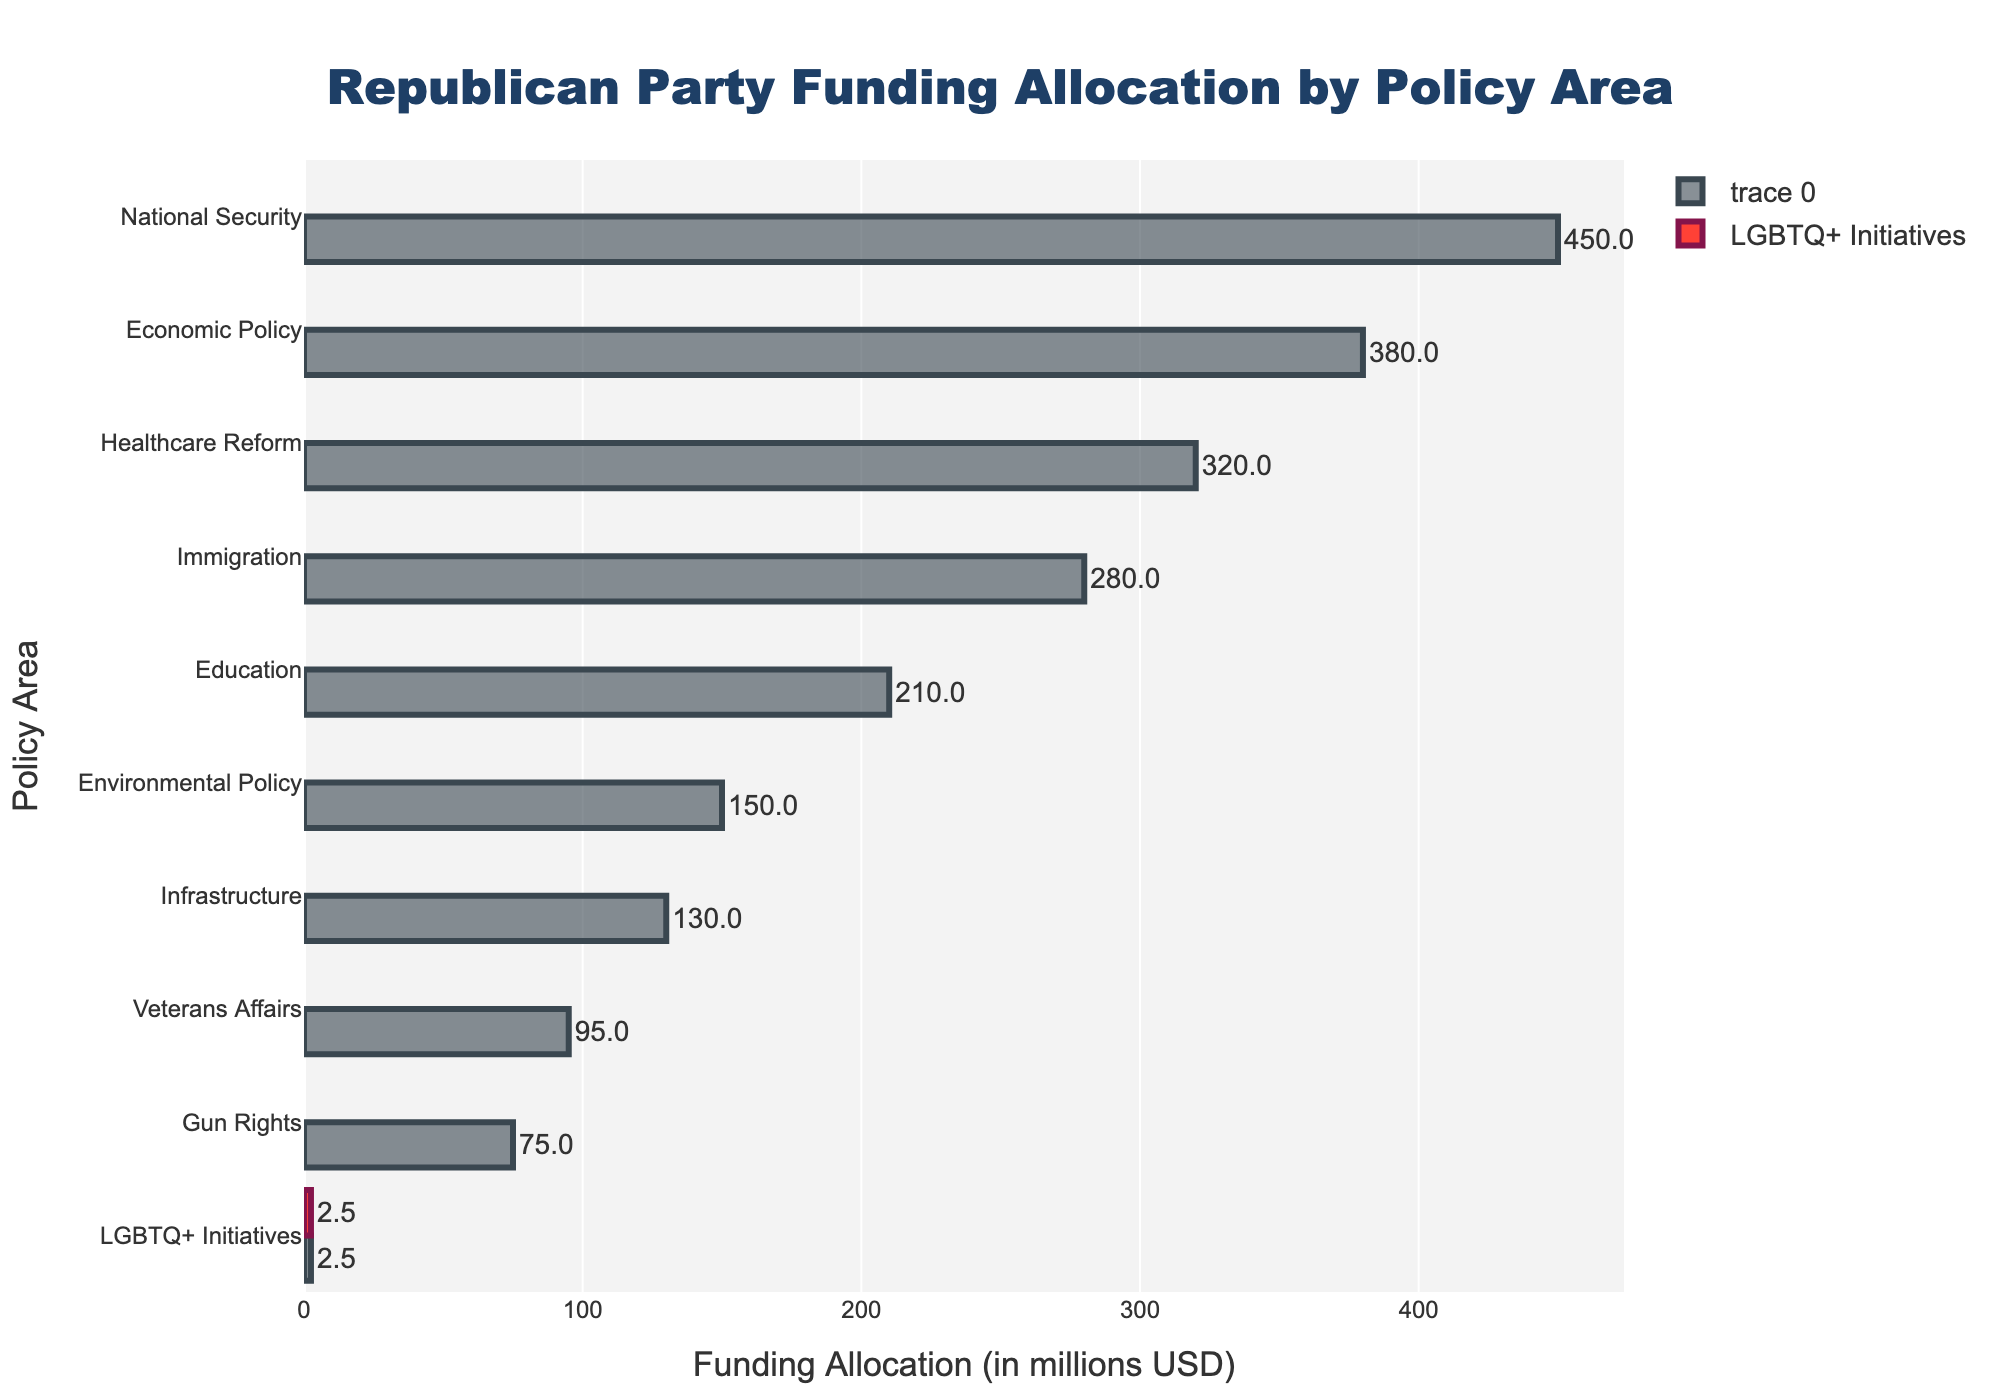How much more funding is allocated to National Security compared to LGBTQ+ Initiatives? The funding for National Security is 450 million USD, and the funding for LGBTQ+ Initiatives is 2.5 million USD. The difference is 450 - 2.5 = 447.5 million USD.
Answer: 447.5 million USD What is the total funding allocation for Economic Policy, Healthcare Reform, and Immigration combined? The funding for Economic Policy is 380 million USD, for Healthcare Reform is 320 million USD, and for Immigration is 280 million USD. The sum is 380 + 320 + 280 = 980 million USD.
Answer: 980 million USD Rank the policy areas from highest to lowest funding allocation. By looking at the bar lengths, the ranking from highest to lowest funding allocation is National Security, Economic Policy, Healthcare Reform, Immigration, Education, Environmental Policy, Infrastructure, Veterans Affairs, Gun Rights, LGBTQ+ Initiatives.
Answer: National Security, Economic Policy, Healthcare Reform, Immigration, Education, Environmental Policy, Infrastructure, Veterans Affairs, Gun Rights, LGBTQ+ Initiatives Which policy area receives the least funding and by how much less than the second least funded area? The policy area receiving the least funding is LGBTQ+ Initiatives with 2.5 million USD, and the second least is Gun Rights with 75 million USD. The difference is 75 - 2.5 = 72.5 million USD.
Answer: LGBTQ+ Initiatives, 72.5 million USD What is the average funding allocation of all policy areas? Sum the funding allocations: 2.5 + 450 + 380 + 320 + 280 + 210 + 150 + 130 + 95 + 75 = 2092.5 million USD. There are 10 policy areas, so, the average is 2092.5 / 10 = 209.25 million USD.
Answer: 209.25 million USD How many policy areas have more than 200 million USD in funding allocation? The policy areas with more than 200 million USD in funding are National Security, Economic Policy, Healthcare Reform, Immigration, and Education. There are 5 such areas.
Answer: 5 What is the funding difference between the top three policy areas and the bottom three policy areas? The top three policy areas are National Security (450), Economic Policy (380), and Healthcare Reform (320), summing to 1150 million USD. The bottom three are LGBTQ+ Initiatives (2.5), Gun Rights (75), and Veterans Affairs (95), summing to 172.5 million USD. The difference is 1150 - 172.5 = 977.5 million USD.
Answer: 977.5 million USD 